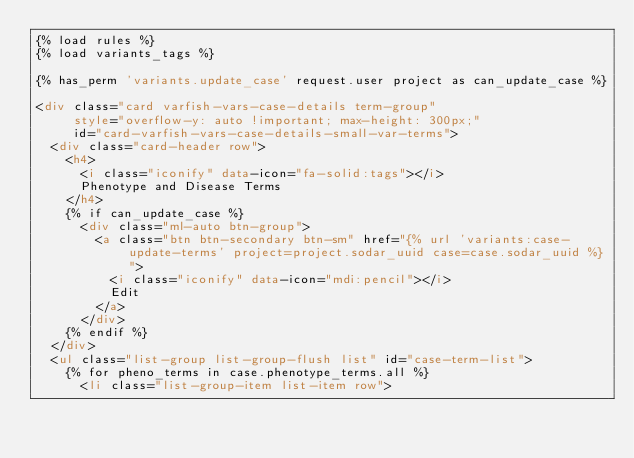Convert code to text. <code><loc_0><loc_0><loc_500><loc_500><_HTML_>{% load rules %}
{% load variants_tags %}

{% has_perm 'variants.update_case' request.user project as can_update_case %}

<div class="card varfish-vars-case-details term-group"
     style="overflow-y: auto !important; max-height: 300px;"
     id="card-varfish-vars-case-details-small-var-terms">
  <div class="card-header row">
    <h4>
      <i class="iconify" data-icon="fa-solid:tags"></i>
      Phenotype and Disease Terms
    </h4>
    {% if can_update_case %}
      <div class="ml-auto btn-group">
        <a class="btn btn-secondary btn-sm" href="{% url 'variants:case-update-terms' project=project.sodar_uuid case=case.sodar_uuid %}">
          <i class="iconify" data-icon="mdi:pencil"></i>
          Edit
        </a>
      </div>
    {% endif %}
  </div>
  <ul class="list-group list-group-flush list" id="case-term-list">
    {% for pheno_terms in case.phenotype_terms.all %}
      <li class="list-group-item list-item row"></code> 